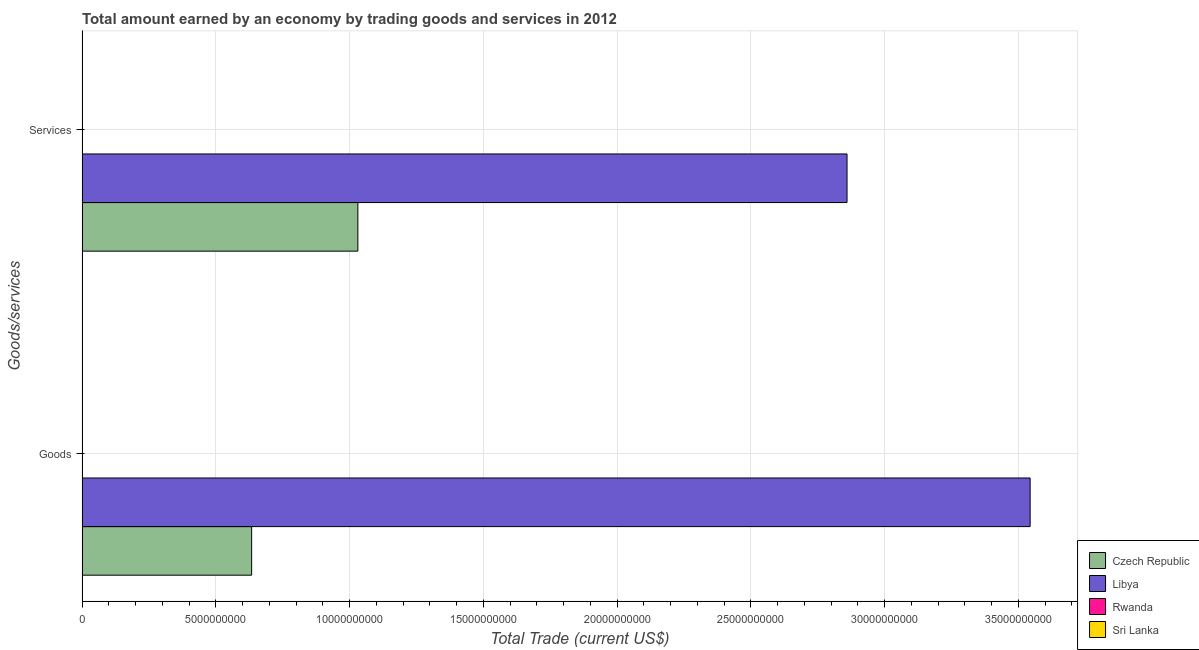How many different coloured bars are there?
Provide a succinct answer. 2. How many groups of bars are there?
Ensure brevity in your answer.  2. Are the number of bars per tick equal to the number of legend labels?
Keep it short and to the point. No. Are the number of bars on each tick of the Y-axis equal?
Your answer should be compact. Yes. How many bars are there on the 2nd tick from the bottom?
Give a very brief answer. 2. What is the label of the 1st group of bars from the top?
Offer a terse response. Services. What is the amount earned by trading services in Libya?
Your response must be concise. 2.86e+1. Across all countries, what is the maximum amount earned by trading goods?
Ensure brevity in your answer.  3.54e+1. In which country was the amount earned by trading goods maximum?
Offer a very short reply. Libya. What is the total amount earned by trading goods in the graph?
Ensure brevity in your answer.  4.18e+1. What is the difference between the amount earned by trading goods in Libya and that in Czech Republic?
Ensure brevity in your answer.  2.91e+1. What is the difference between the amount earned by trading goods in Libya and the amount earned by trading services in Rwanda?
Offer a very short reply. 3.54e+1. What is the average amount earned by trading goods per country?
Provide a succinct answer. 1.04e+1. What is the difference between the amount earned by trading services and amount earned by trading goods in Czech Republic?
Your answer should be very brief. 3.97e+09. What is the ratio of the amount earned by trading services in Libya to that in Czech Republic?
Offer a terse response. 2.77. Is the amount earned by trading services in Libya less than that in Czech Republic?
Your response must be concise. No. In how many countries, is the amount earned by trading goods greater than the average amount earned by trading goods taken over all countries?
Provide a succinct answer. 1. How many countries are there in the graph?
Ensure brevity in your answer.  4. What is the difference between two consecutive major ticks on the X-axis?
Make the answer very short. 5.00e+09. Does the graph contain any zero values?
Your response must be concise. Yes. Where does the legend appear in the graph?
Your answer should be very brief. Bottom right. How are the legend labels stacked?
Offer a very short reply. Vertical. What is the title of the graph?
Make the answer very short. Total amount earned by an economy by trading goods and services in 2012. What is the label or title of the X-axis?
Your answer should be very brief. Total Trade (current US$). What is the label or title of the Y-axis?
Keep it short and to the point. Goods/services. What is the Total Trade (current US$) in Czech Republic in Goods?
Ensure brevity in your answer.  6.34e+09. What is the Total Trade (current US$) of Libya in Goods?
Your answer should be very brief. 3.54e+1. What is the Total Trade (current US$) in Czech Republic in Services?
Provide a short and direct response. 1.03e+1. What is the Total Trade (current US$) in Libya in Services?
Ensure brevity in your answer.  2.86e+1. What is the Total Trade (current US$) of Rwanda in Services?
Provide a short and direct response. 0. What is the Total Trade (current US$) in Sri Lanka in Services?
Your answer should be very brief. 0. Across all Goods/services, what is the maximum Total Trade (current US$) in Czech Republic?
Provide a short and direct response. 1.03e+1. Across all Goods/services, what is the maximum Total Trade (current US$) of Libya?
Give a very brief answer. 3.54e+1. Across all Goods/services, what is the minimum Total Trade (current US$) in Czech Republic?
Provide a succinct answer. 6.34e+09. Across all Goods/services, what is the minimum Total Trade (current US$) of Libya?
Your answer should be very brief. 2.86e+1. What is the total Total Trade (current US$) in Czech Republic in the graph?
Provide a short and direct response. 1.66e+1. What is the total Total Trade (current US$) of Libya in the graph?
Ensure brevity in your answer.  6.40e+1. What is the total Total Trade (current US$) of Sri Lanka in the graph?
Your answer should be compact. 0. What is the difference between the Total Trade (current US$) in Czech Republic in Goods and that in Services?
Keep it short and to the point. -3.97e+09. What is the difference between the Total Trade (current US$) of Libya in Goods and that in Services?
Make the answer very short. 6.84e+09. What is the difference between the Total Trade (current US$) of Czech Republic in Goods and the Total Trade (current US$) of Libya in Services?
Provide a succinct answer. -2.23e+1. What is the average Total Trade (current US$) of Czech Republic per Goods/services?
Your answer should be compact. 8.32e+09. What is the average Total Trade (current US$) in Libya per Goods/services?
Keep it short and to the point. 3.20e+1. What is the average Total Trade (current US$) of Rwanda per Goods/services?
Provide a short and direct response. 0. What is the difference between the Total Trade (current US$) of Czech Republic and Total Trade (current US$) of Libya in Goods?
Offer a terse response. -2.91e+1. What is the difference between the Total Trade (current US$) in Czech Republic and Total Trade (current US$) in Libya in Services?
Offer a terse response. -1.83e+1. What is the ratio of the Total Trade (current US$) of Czech Republic in Goods to that in Services?
Keep it short and to the point. 0.61. What is the ratio of the Total Trade (current US$) in Libya in Goods to that in Services?
Your response must be concise. 1.24. What is the difference between the highest and the second highest Total Trade (current US$) in Czech Republic?
Offer a very short reply. 3.97e+09. What is the difference between the highest and the second highest Total Trade (current US$) in Libya?
Give a very brief answer. 6.84e+09. What is the difference between the highest and the lowest Total Trade (current US$) of Czech Republic?
Your answer should be compact. 3.97e+09. What is the difference between the highest and the lowest Total Trade (current US$) of Libya?
Provide a short and direct response. 6.84e+09. 